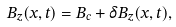Convert formula to latex. <formula><loc_0><loc_0><loc_500><loc_500>B _ { z } ( x , t ) = B _ { c } + \delta B _ { z } ( x , t ) ,</formula> 